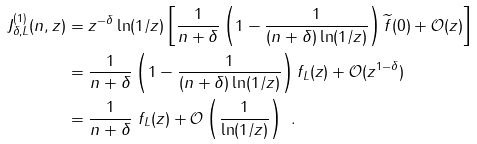Convert formula to latex. <formula><loc_0><loc_0><loc_500><loc_500>J ^ { ( 1 ) } _ { \delta , L } ( n , z ) & = z ^ { - \delta } \ln ( 1 / z ) \left [ \frac { 1 } { n + \delta } \left ( 1 - \frac { 1 } { ( n + \delta ) \ln ( 1 / z ) } \right ) \widetilde { f } ( 0 ) + \mathcal { O } ( z ) \right ] \\ & = \frac { 1 } { n + \delta } \left ( 1 - \frac { 1 } { ( n + \delta ) \ln ( 1 / z ) } \right ) f _ { L } ( z ) + \mathcal { O } ( z ^ { 1 - \delta } ) \\ & = \frac { 1 } { n + \delta } \ f _ { L } ( z ) + \mathcal { O } \left ( \frac { 1 } { \ln ( 1 / z ) } \right ) \ .</formula> 